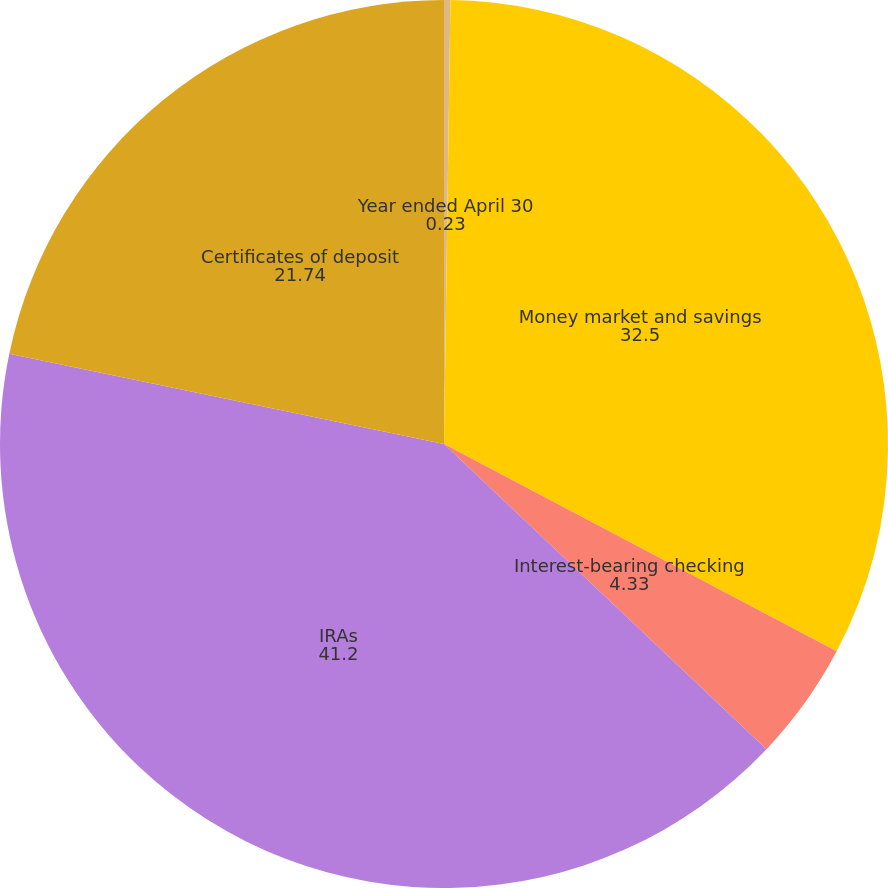Convert chart. <chart><loc_0><loc_0><loc_500><loc_500><pie_chart><fcel>Year ended April 30<fcel>Money market and savings<fcel>Interest-bearing checking<fcel>IRAs<fcel>Certificates of deposit<nl><fcel>0.23%<fcel>32.5%<fcel>4.33%<fcel>41.2%<fcel>21.74%<nl></chart> 